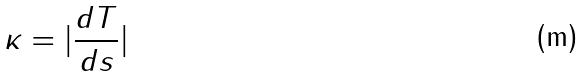<formula> <loc_0><loc_0><loc_500><loc_500>\kappa = | \frac { d T } { d s } |</formula> 